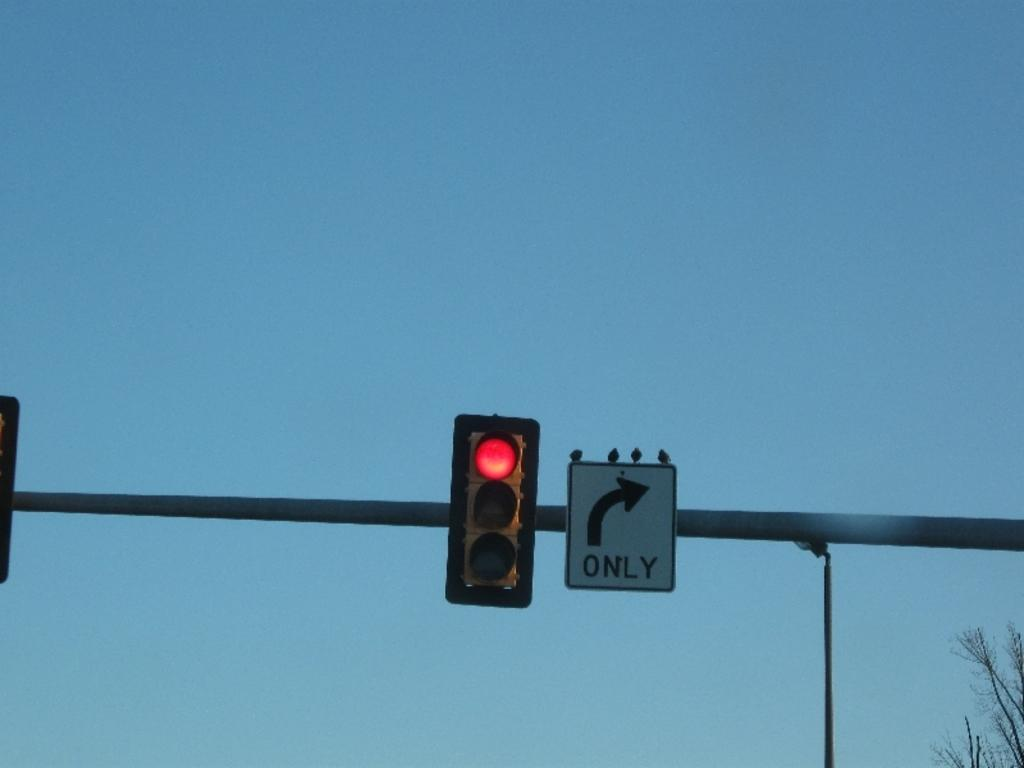<image>
Present a compact description of the photo's key features. the word only is on the sign with an arrow 